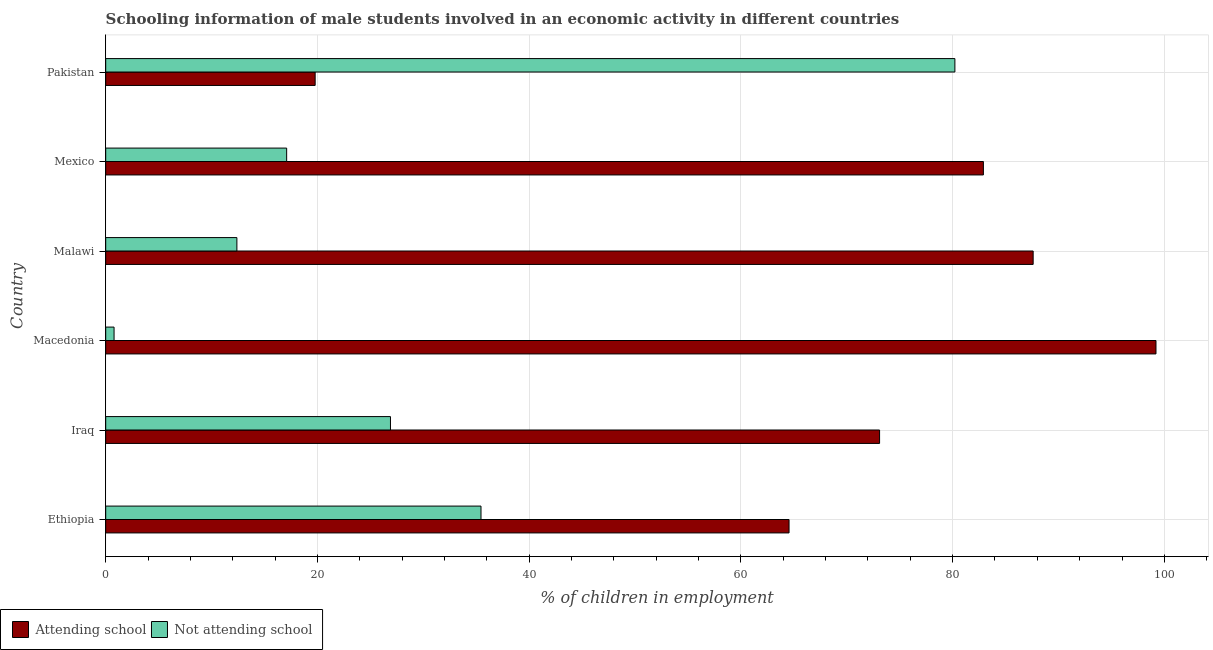How many groups of bars are there?
Give a very brief answer. 6. Are the number of bars per tick equal to the number of legend labels?
Your answer should be very brief. Yes. What is the label of the 6th group of bars from the top?
Make the answer very short. Ethiopia. In how many cases, is the number of bars for a given country not equal to the number of legend labels?
Make the answer very short. 0. What is the percentage of employed males who are attending school in Macedonia?
Your answer should be compact. 99.21. Across all countries, what is the maximum percentage of employed males who are attending school?
Your answer should be very brief. 99.21. Across all countries, what is the minimum percentage of employed males who are not attending school?
Make the answer very short. 0.79. In which country was the percentage of employed males who are attending school maximum?
Your response must be concise. Macedonia. In which country was the percentage of employed males who are not attending school minimum?
Provide a succinct answer. Macedonia. What is the total percentage of employed males who are attending school in the graph?
Offer a very short reply. 427.16. What is the difference between the percentage of employed males who are not attending school in Macedonia and that in Mexico?
Offer a very short reply. -16.3. What is the difference between the percentage of employed males who are attending school in Mexico and the percentage of employed males who are not attending school in Iraq?
Offer a very short reply. 56.01. What is the average percentage of employed males who are attending school per country?
Offer a terse response. 71.19. What is the difference between the percentage of employed males who are not attending school and percentage of employed males who are attending school in Pakistan?
Your answer should be very brief. 60.43. What is the ratio of the percentage of employed males who are not attending school in Ethiopia to that in Iraq?
Your answer should be very brief. 1.32. Is the percentage of employed males who are not attending school in Malawi less than that in Pakistan?
Provide a succinct answer. Yes. What is the difference between the highest and the second highest percentage of employed males who are not attending school?
Provide a succinct answer. 44.76. What is the difference between the highest and the lowest percentage of employed males who are not attending school?
Give a very brief answer. 79.42. In how many countries, is the percentage of employed males who are not attending school greater than the average percentage of employed males who are not attending school taken over all countries?
Make the answer very short. 2. What does the 1st bar from the top in Ethiopia represents?
Offer a very short reply. Not attending school. What does the 2nd bar from the bottom in Mexico represents?
Your answer should be compact. Not attending school. How many countries are there in the graph?
Give a very brief answer. 6. Where does the legend appear in the graph?
Provide a succinct answer. Bottom left. How many legend labels are there?
Your response must be concise. 2. How are the legend labels stacked?
Keep it short and to the point. Horizontal. What is the title of the graph?
Your answer should be very brief. Schooling information of male students involved in an economic activity in different countries. Does "Number of departures" appear as one of the legend labels in the graph?
Provide a succinct answer. No. What is the label or title of the X-axis?
Offer a very short reply. % of children in employment. What is the label or title of the Y-axis?
Give a very brief answer. Country. What is the % of children in employment in Attending school in Ethiopia?
Offer a very short reply. 64.55. What is the % of children in employment in Not attending school in Ethiopia?
Keep it short and to the point. 35.45. What is the % of children in employment in Attending school in Iraq?
Your answer should be compact. 73.1. What is the % of children in employment of Not attending school in Iraq?
Give a very brief answer. 26.9. What is the % of children in employment of Attending school in Macedonia?
Provide a succinct answer. 99.21. What is the % of children in employment of Not attending school in Macedonia?
Ensure brevity in your answer.  0.79. What is the % of children in employment of Attending school in Malawi?
Make the answer very short. 87.61. What is the % of children in employment of Not attending school in Malawi?
Your answer should be compact. 12.39. What is the % of children in employment in Attending school in Mexico?
Offer a terse response. 82.91. What is the % of children in employment in Not attending school in Mexico?
Give a very brief answer. 17.09. What is the % of children in employment in Attending school in Pakistan?
Provide a succinct answer. 19.79. What is the % of children in employment of Not attending school in Pakistan?
Ensure brevity in your answer.  80.21. Across all countries, what is the maximum % of children in employment of Attending school?
Provide a short and direct response. 99.21. Across all countries, what is the maximum % of children in employment of Not attending school?
Your answer should be compact. 80.21. Across all countries, what is the minimum % of children in employment of Attending school?
Your answer should be compact. 19.79. Across all countries, what is the minimum % of children in employment in Not attending school?
Offer a very short reply. 0.79. What is the total % of children in employment of Attending school in the graph?
Provide a succinct answer. 427.16. What is the total % of children in employment of Not attending school in the graph?
Offer a very short reply. 172.84. What is the difference between the % of children in employment of Attending school in Ethiopia and that in Iraq?
Your answer should be compact. -8.55. What is the difference between the % of children in employment in Not attending school in Ethiopia and that in Iraq?
Make the answer very short. 8.55. What is the difference between the % of children in employment in Attending school in Ethiopia and that in Macedonia?
Give a very brief answer. -34.66. What is the difference between the % of children in employment of Not attending school in Ethiopia and that in Macedonia?
Give a very brief answer. 34.66. What is the difference between the % of children in employment of Attending school in Ethiopia and that in Malawi?
Offer a terse response. -23.06. What is the difference between the % of children in employment in Not attending school in Ethiopia and that in Malawi?
Keep it short and to the point. 23.06. What is the difference between the % of children in employment in Attending school in Ethiopia and that in Mexico?
Provide a short and direct response. -18.36. What is the difference between the % of children in employment of Not attending school in Ethiopia and that in Mexico?
Your answer should be very brief. 18.36. What is the difference between the % of children in employment of Attending school in Ethiopia and that in Pakistan?
Offer a very short reply. 44.76. What is the difference between the % of children in employment in Not attending school in Ethiopia and that in Pakistan?
Offer a very short reply. -44.76. What is the difference between the % of children in employment of Attending school in Iraq and that in Macedonia?
Your response must be concise. -26.11. What is the difference between the % of children in employment of Not attending school in Iraq and that in Macedonia?
Your response must be concise. 26.11. What is the difference between the % of children in employment of Attending school in Iraq and that in Malawi?
Your answer should be very brief. -14.51. What is the difference between the % of children in employment in Not attending school in Iraq and that in Malawi?
Provide a short and direct response. 14.51. What is the difference between the % of children in employment of Attending school in Iraq and that in Mexico?
Your response must be concise. -9.81. What is the difference between the % of children in employment in Not attending school in Iraq and that in Mexico?
Provide a short and direct response. 9.81. What is the difference between the % of children in employment of Attending school in Iraq and that in Pakistan?
Provide a short and direct response. 53.31. What is the difference between the % of children in employment of Not attending school in Iraq and that in Pakistan?
Offer a terse response. -53.31. What is the difference between the % of children in employment in Attending school in Macedonia and that in Malawi?
Provide a short and direct response. 11.6. What is the difference between the % of children in employment of Not attending school in Macedonia and that in Malawi?
Your response must be concise. -11.6. What is the difference between the % of children in employment in Attending school in Macedonia and that in Mexico?
Keep it short and to the point. 16.3. What is the difference between the % of children in employment of Not attending school in Macedonia and that in Mexico?
Your answer should be very brief. -16.3. What is the difference between the % of children in employment of Attending school in Macedonia and that in Pakistan?
Your answer should be very brief. 79.42. What is the difference between the % of children in employment of Not attending school in Macedonia and that in Pakistan?
Make the answer very short. -79.42. What is the difference between the % of children in employment in Attending school in Malawi and that in Pakistan?
Ensure brevity in your answer.  67.82. What is the difference between the % of children in employment of Not attending school in Malawi and that in Pakistan?
Ensure brevity in your answer.  -67.82. What is the difference between the % of children in employment of Attending school in Mexico and that in Pakistan?
Keep it short and to the point. 63.12. What is the difference between the % of children in employment of Not attending school in Mexico and that in Pakistan?
Provide a short and direct response. -63.12. What is the difference between the % of children in employment of Attending school in Ethiopia and the % of children in employment of Not attending school in Iraq?
Your response must be concise. 37.65. What is the difference between the % of children in employment in Attending school in Ethiopia and the % of children in employment in Not attending school in Macedonia?
Provide a short and direct response. 63.76. What is the difference between the % of children in employment of Attending school in Ethiopia and the % of children in employment of Not attending school in Malawi?
Keep it short and to the point. 52.16. What is the difference between the % of children in employment in Attending school in Ethiopia and the % of children in employment in Not attending school in Mexico?
Offer a very short reply. 47.46. What is the difference between the % of children in employment in Attending school in Ethiopia and the % of children in employment in Not attending school in Pakistan?
Offer a very short reply. -15.66. What is the difference between the % of children in employment in Attending school in Iraq and the % of children in employment in Not attending school in Macedonia?
Make the answer very short. 72.31. What is the difference between the % of children in employment in Attending school in Iraq and the % of children in employment in Not attending school in Malawi?
Provide a short and direct response. 60.71. What is the difference between the % of children in employment in Attending school in Iraq and the % of children in employment in Not attending school in Mexico?
Ensure brevity in your answer.  56.01. What is the difference between the % of children in employment of Attending school in Iraq and the % of children in employment of Not attending school in Pakistan?
Provide a succinct answer. -7.11. What is the difference between the % of children in employment in Attending school in Macedonia and the % of children in employment in Not attending school in Malawi?
Your answer should be compact. 86.82. What is the difference between the % of children in employment in Attending school in Macedonia and the % of children in employment in Not attending school in Mexico?
Provide a short and direct response. 82.12. What is the difference between the % of children in employment in Attending school in Macedonia and the % of children in employment in Not attending school in Pakistan?
Make the answer very short. 19. What is the difference between the % of children in employment in Attending school in Malawi and the % of children in employment in Not attending school in Mexico?
Your response must be concise. 70.51. What is the difference between the % of children in employment of Attending school in Malawi and the % of children in employment of Not attending school in Pakistan?
Keep it short and to the point. 7.39. What is the difference between the % of children in employment of Attending school in Mexico and the % of children in employment of Not attending school in Pakistan?
Your response must be concise. 2.69. What is the average % of children in employment of Attending school per country?
Ensure brevity in your answer.  71.19. What is the average % of children in employment in Not attending school per country?
Your answer should be compact. 28.81. What is the difference between the % of children in employment in Attending school and % of children in employment in Not attending school in Ethiopia?
Offer a very short reply. 29.1. What is the difference between the % of children in employment of Attending school and % of children in employment of Not attending school in Iraq?
Your response must be concise. 46.2. What is the difference between the % of children in employment in Attending school and % of children in employment in Not attending school in Macedonia?
Offer a very short reply. 98.42. What is the difference between the % of children in employment of Attending school and % of children in employment of Not attending school in Malawi?
Make the answer very short. 75.21. What is the difference between the % of children in employment in Attending school and % of children in employment in Not attending school in Mexico?
Your response must be concise. 65.81. What is the difference between the % of children in employment of Attending school and % of children in employment of Not attending school in Pakistan?
Offer a very short reply. -60.43. What is the ratio of the % of children in employment of Attending school in Ethiopia to that in Iraq?
Provide a short and direct response. 0.88. What is the ratio of the % of children in employment in Not attending school in Ethiopia to that in Iraq?
Keep it short and to the point. 1.32. What is the ratio of the % of children in employment of Attending school in Ethiopia to that in Macedonia?
Make the answer very short. 0.65. What is the ratio of the % of children in employment in Not attending school in Ethiopia to that in Macedonia?
Ensure brevity in your answer.  44.84. What is the ratio of the % of children in employment of Attending school in Ethiopia to that in Malawi?
Keep it short and to the point. 0.74. What is the ratio of the % of children in employment in Not attending school in Ethiopia to that in Malawi?
Your response must be concise. 2.86. What is the ratio of the % of children in employment in Attending school in Ethiopia to that in Mexico?
Offer a very short reply. 0.78. What is the ratio of the % of children in employment of Not attending school in Ethiopia to that in Mexico?
Your answer should be very brief. 2.07. What is the ratio of the % of children in employment of Attending school in Ethiopia to that in Pakistan?
Your answer should be compact. 3.26. What is the ratio of the % of children in employment of Not attending school in Ethiopia to that in Pakistan?
Give a very brief answer. 0.44. What is the ratio of the % of children in employment of Attending school in Iraq to that in Macedonia?
Give a very brief answer. 0.74. What is the ratio of the % of children in employment in Not attending school in Iraq to that in Macedonia?
Your answer should be compact. 34.02. What is the ratio of the % of children in employment in Attending school in Iraq to that in Malawi?
Keep it short and to the point. 0.83. What is the ratio of the % of children in employment of Not attending school in Iraq to that in Malawi?
Offer a terse response. 2.17. What is the ratio of the % of children in employment in Attending school in Iraq to that in Mexico?
Your answer should be compact. 0.88. What is the ratio of the % of children in employment in Not attending school in Iraq to that in Mexico?
Your answer should be compact. 1.57. What is the ratio of the % of children in employment in Attending school in Iraq to that in Pakistan?
Your answer should be very brief. 3.69. What is the ratio of the % of children in employment in Not attending school in Iraq to that in Pakistan?
Make the answer very short. 0.34. What is the ratio of the % of children in employment of Attending school in Macedonia to that in Malawi?
Offer a terse response. 1.13. What is the ratio of the % of children in employment in Not attending school in Macedonia to that in Malawi?
Offer a terse response. 0.06. What is the ratio of the % of children in employment of Attending school in Macedonia to that in Mexico?
Provide a succinct answer. 1.2. What is the ratio of the % of children in employment of Not attending school in Macedonia to that in Mexico?
Offer a terse response. 0.05. What is the ratio of the % of children in employment in Attending school in Macedonia to that in Pakistan?
Make the answer very short. 5.01. What is the ratio of the % of children in employment in Not attending school in Macedonia to that in Pakistan?
Make the answer very short. 0.01. What is the ratio of the % of children in employment of Attending school in Malawi to that in Mexico?
Provide a succinct answer. 1.06. What is the ratio of the % of children in employment in Not attending school in Malawi to that in Mexico?
Your answer should be compact. 0.72. What is the ratio of the % of children in employment in Attending school in Malawi to that in Pakistan?
Offer a very short reply. 4.43. What is the ratio of the % of children in employment in Not attending school in Malawi to that in Pakistan?
Offer a terse response. 0.15. What is the ratio of the % of children in employment of Attending school in Mexico to that in Pakistan?
Provide a short and direct response. 4.19. What is the ratio of the % of children in employment in Not attending school in Mexico to that in Pakistan?
Your answer should be compact. 0.21. What is the difference between the highest and the second highest % of children in employment of Attending school?
Ensure brevity in your answer.  11.6. What is the difference between the highest and the second highest % of children in employment of Not attending school?
Your answer should be very brief. 44.76. What is the difference between the highest and the lowest % of children in employment in Attending school?
Ensure brevity in your answer.  79.42. What is the difference between the highest and the lowest % of children in employment in Not attending school?
Your answer should be compact. 79.42. 